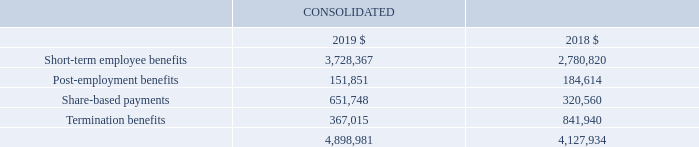Section 5: Our people
We are working to attract and retain employees with the skills and passion to best serve our markets. This section provides information about our employee benefits obligations. It also includes details of our employee share plans and compensation paid to key management personnel.
5.1 Key management personnel compensation
Key management personnel (KMP) refers to those who have authority and responsibility for planning, directing and controlling the activities of the Group. For a list of key management personnel and additional disclosures, refer to the remuneration report on pages 38 to 53.
KMP aggregate compensation
During the financial years 2019 and 2018, the aggregate compensation provided to KMP was as follows:
Other transactions with our KMP and their related parties
During the financial years 2019 and 2018, apart from transactions disclosed in note 7.2 of the financial report, there were no other transactions with our KMP and their related parties.
What is the short-term employee benefits in 2019? 3,728,367. What is the post-employment benefits in 2018? 184,614. What is the share-based payments in 2019? 651,748. What is the percentage change in short-term employee benefits from 2018 to 2019?
Answer scale should be: percent. (3,728,367-2,780,820)/2,780,820
Answer: 34.07. What is the percentage change in the post-employment benefits from 2018 to 2019?
Answer scale should be: percent. (151,851-184,614)/184,614
Answer: -17.75. What is the percentage change in the termination benefits from 2018 to 2019?
Answer scale should be: percent. (367,015-841,940)/841,940
Answer: -56.41. 